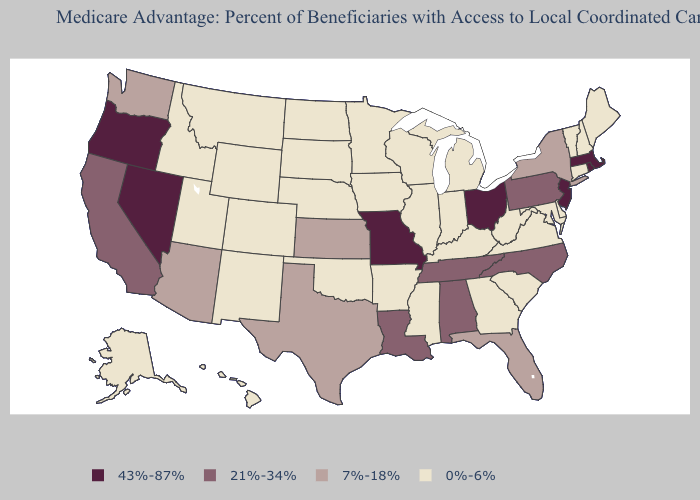Name the states that have a value in the range 21%-34%?
Answer briefly. Alabama, California, Louisiana, North Carolina, Pennsylvania, Tennessee. Does Washington have the highest value in the USA?
Short answer required. No. Among the states that border Minnesota , which have the highest value?
Give a very brief answer. Iowa, North Dakota, South Dakota, Wisconsin. Does Missouri have the highest value in the MidWest?
Short answer required. Yes. What is the lowest value in the USA?
Give a very brief answer. 0%-6%. Does the first symbol in the legend represent the smallest category?
Be succinct. No. Does New Mexico have the highest value in the West?
Answer briefly. No. How many symbols are there in the legend?
Quick response, please. 4. What is the highest value in states that border Arizona?
Give a very brief answer. 43%-87%. Name the states that have a value in the range 21%-34%?
Write a very short answer. Alabama, California, Louisiana, North Carolina, Pennsylvania, Tennessee. Which states have the lowest value in the South?
Answer briefly. Arkansas, Delaware, Georgia, Kentucky, Maryland, Mississippi, Oklahoma, South Carolina, Virginia, West Virginia. What is the value of West Virginia?
Answer briefly. 0%-6%. What is the value of South Carolina?
Concise answer only. 0%-6%. Name the states that have a value in the range 43%-87%?
Be succinct. Massachusetts, Missouri, New Jersey, Nevada, Ohio, Oregon, Rhode Island. 